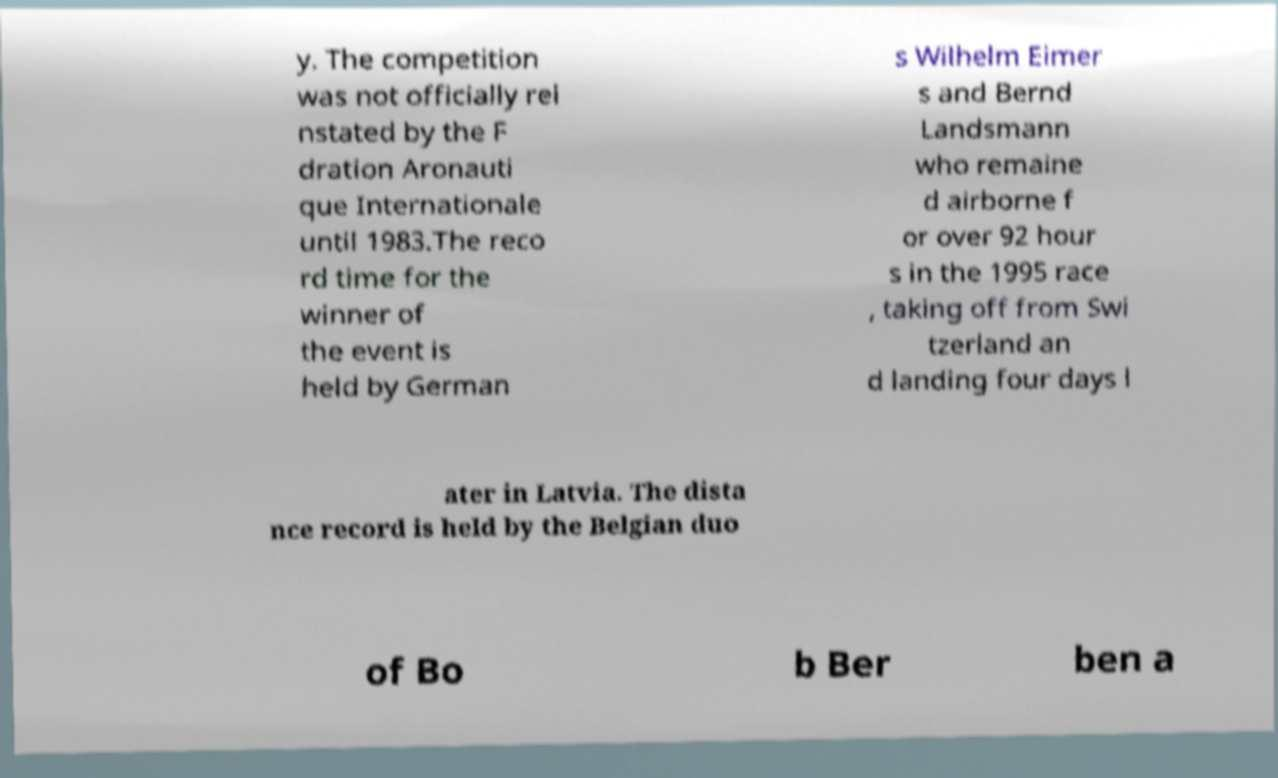Please identify and transcribe the text found in this image. y. The competition was not officially rei nstated by the F dration Aronauti que Internationale until 1983.The reco rd time for the winner of the event is held by German s Wilhelm Eimer s and Bernd Landsmann who remaine d airborne f or over 92 hour s in the 1995 race , taking off from Swi tzerland an d landing four days l ater in Latvia. The dista nce record is held by the Belgian duo of Bo b Ber ben a 